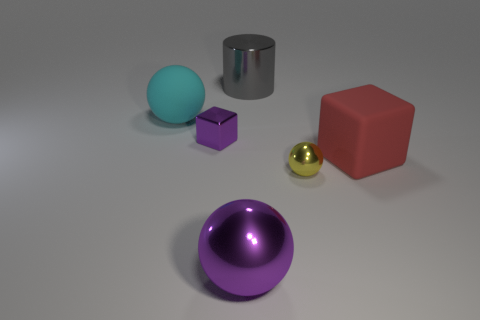The big matte cube has what color?
Ensure brevity in your answer.  Red. There is a object in front of the tiny ball; does it have the same size as the purple metallic object behind the small yellow shiny thing?
Keep it short and to the point. No. What size is the metallic object that is behind the red rubber block and in front of the gray object?
Offer a terse response. Small. What is the color of the big rubber thing that is the same shape as the tiny purple shiny object?
Your response must be concise. Red. Are there more cyan rubber balls that are in front of the tiny purple metal cube than big gray shiny cylinders that are to the left of the large purple ball?
Make the answer very short. No. What number of other objects are there of the same shape as the large red object?
Your answer should be very brief. 1. There is a tiny thing that is on the right side of the big gray object; are there any big red rubber blocks left of it?
Offer a very short reply. No. How many large rubber things are there?
Keep it short and to the point. 2. There is a shiny cylinder; is it the same color as the tiny object right of the gray metal cylinder?
Your response must be concise. No. Are there more red rubber things than large purple shiny blocks?
Make the answer very short. Yes. 